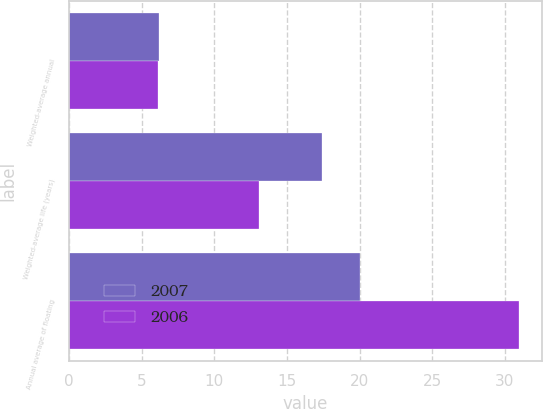Convert chart to OTSL. <chart><loc_0><loc_0><loc_500><loc_500><stacked_bar_chart><ecel><fcel>Weighted-average annual<fcel>Weighted-average life (years)<fcel>Annual average of floating<nl><fcel>2007<fcel>6.2<fcel>17.4<fcel>20<nl><fcel>2006<fcel>6.1<fcel>13.1<fcel>31<nl></chart> 